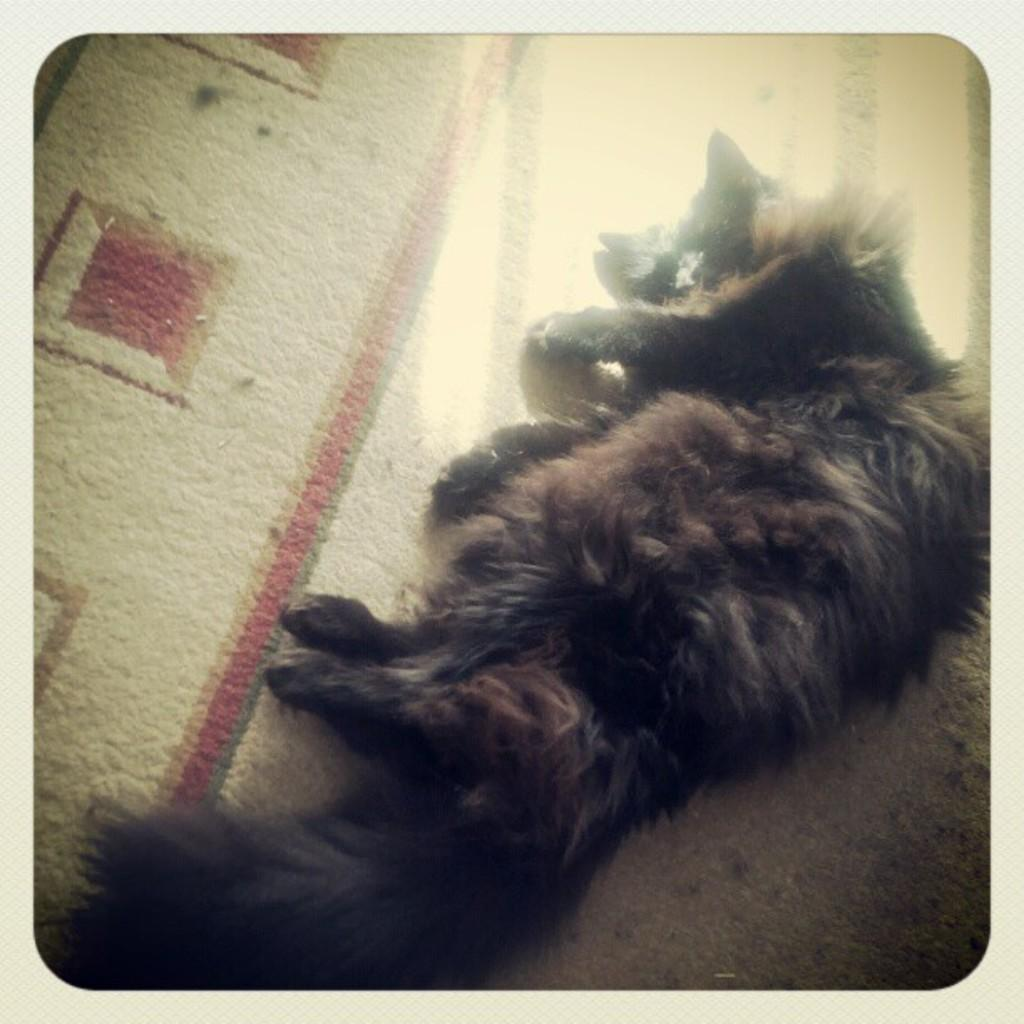What type of animal is in the image? There is a black dog in the image. What is the dog doing in the image? The dog is lying on the floor. On which side of the image is the dog located? The dog is on the right side of the image. What can be seen on the carpet in the image? There is sunlight visible on the carpet in the image. What type of bead is the baby playing with in the image? There is no baby or bead present in the image; it features a black dog lying on the floor. 